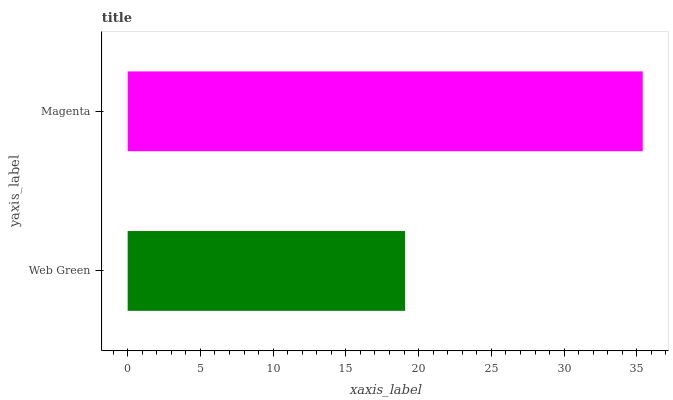Is Web Green the minimum?
Answer yes or no. Yes. Is Magenta the maximum?
Answer yes or no. Yes. Is Magenta the minimum?
Answer yes or no. No. Is Magenta greater than Web Green?
Answer yes or no. Yes. Is Web Green less than Magenta?
Answer yes or no. Yes. Is Web Green greater than Magenta?
Answer yes or no. No. Is Magenta less than Web Green?
Answer yes or no. No. Is Magenta the high median?
Answer yes or no. Yes. Is Web Green the low median?
Answer yes or no. Yes. Is Web Green the high median?
Answer yes or no. No. Is Magenta the low median?
Answer yes or no. No. 